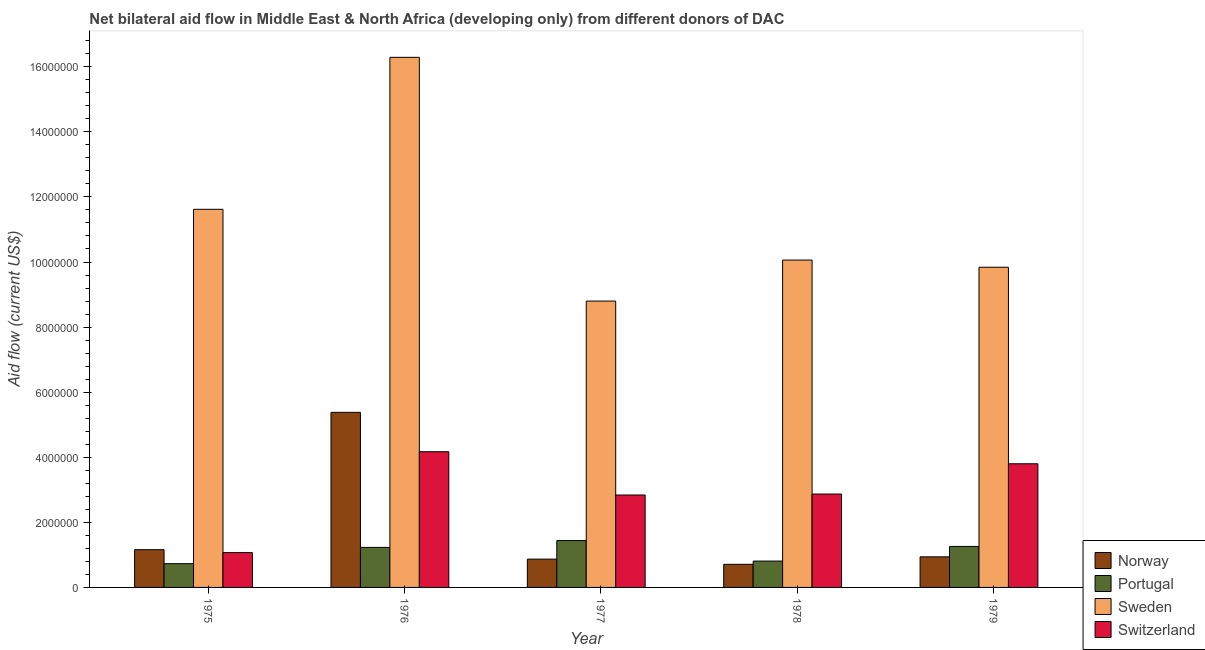How many different coloured bars are there?
Ensure brevity in your answer.  4. Are the number of bars per tick equal to the number of legend labels?
Your answer should be very brief. Yes. Are the number of bars on each tick of the X-axis equal?
Offer a very short reply. Yes. How many bars are there on the 5th tick from the left?
Provide a succinct answer. 4. What is the label of the 1st group of bars from the left?
Provide a succinct answer. 1975. In how many cases, is the number of bars for a given year not equal to the number of legend labels?
Offer a terse response. 0. What is the amount of aid given by norway in 1975?
Offer a very short reply. 1.16e+06. Across all years, what is the maximum amount of aid given by sweden?
Your answer should be very brief. 1.63e+07. Across all years, what is the minimum amount of aid given by norway?
Your response must be concise. 7.10e+05. In which year was the amount of aid given by portugal maximum?
Provide a succinct answer. 1977. In which year was the amount of aid given by portugal minimum?
Keep it short and to the point. 1975. What is the total amount of aid given by portugal in the graph?
Give a very brief answer. 5.47e+06. What is the difference between the amount of aid given by sweden in 1976 and that in 1979?
Keep it short and to the point. 6.45e+06. What is the difference between the amount of aid given by sweden in 1979 and the amount of aid given by portugal in 1975?
Give a very brief answer. -1.78e+06. What is the average amount of aid given by sweden per year?
Keep it short and to the point. 1.13e+07. What is the ratio of the amount of aid given by norway in 1975 to that in 1977?
Your answer should be compact. 1.33. What is the difference between the highest and the second highest amount of aid given by norway?
Ensure brevity in your answer.  4.22e+06. What is the difference between the highest and the lowest amount of aid given by sweden?
Offer a very short reply. 7.49e+06. In how many years, is the amount of aid given by sweden greater than the average amount of aid given by sweden taken over all years?
Your answer should be compact. 2. Is the sum of the amount of aid given by switzerland in 1975 and 1979 greater than the maximum amount of aid given by norway across all years?
Ensure brevity in your answer.  Yes. What does the 2nd bar from the right in 1976 represents?
Provide a succinct answer. Sweden. Are all the bars in the graph horizontal?
Make the answer very short. No. What is the difference between two consecutive major ticks on the Y-axis?
Your answer should be compact. 2.00e+06. Are the values on the major ticks of Y-axis written in scientific E-notation?
Offer a terse response. No. Where does the legend appear in the graph?
Your answer should be compact. Bottom right. What is the title of the graph?
Your answer should be compact. Net bilateral aid flow in Middle East & North Africa (developing only) from different donors of DAC. What is the Aid flow (current US$) of Norway in 1975?
Offer a terse response. 1.16e+06. What is the Aid flow (current US$) in Portugal in 1975?
Ensure brevity in your answer.  7.30e+05. What is the Aid flow (current US$) in Sweden in 1975?
Your answer should be compact. 1.16e+07. What is the Aid flow (current US$) in Switzerland in 1975?
Keep it short and to the point. 1.07e+06. What is the Aid flow (current US$) of Norway in 1976?
Ensure brevity in your answer.  5.38e+06. What is the Aid flow (current US$) in Portugal in 1976?
Your response must be concise. 1.23e+06. What is the Aid flow (current US$) in Sweden in 1976?
Keep it short and to the point. 1.63e+07. What is the Aid flow (current US$) in Switzerland in 1976?
Make the answer very short. 4.17e+06. What is the Aid flow (current US$) in Norway in 1977?
Give a very brief answer. 8.70e+05. What is the Aid flow (current US$) of Portugal in 1977?
Make the answer very short. 1.44e+06. What is the Aid flow (current US$) in Sweden in 1977?
Your response must be concise. 8.80e+06. What is the Aid flow (current US$) in Switzerland in 1977?
Give a very brief answer. 2.84e+06. What is the Aid flow (current US$) in Norway in 1978?
Keep it short and to the point. 7.10e+05. What is the Aid flow (current US$) of Portugal in 1978?
Give a very brief answer. 8.10e+05. What is the Aid flow (current US$) of Sweden in 1978?
Your answer should be very brief. 1.01e+07. What is the Aid flow (current US$) of Switzerland in 1978?
Ensure brevity in your answer.  2.87e+06. What is the Aid flow (current US$) of Norway in 1979?
Offer a very short reply. 9.40e+05. What is the Aid flow (current US$) of Portugal in 1979?
Ensure brevity in your answer.  1.26e+06. What is the Aid flow (current US$) in Sweden in 1979?
Your answer should be compact. 9.84e+06. What is the Aid flow (current US$) of Switzerland in 1979?
Make the answer very short. 3.80e+06. Across all years, what is the maximum Aid flow (current US$) in Norway?
Make the answer very short. 5.38e+06. Across all years, what is the maximum Aid flow (current US$) of Portugal?
Your answer should be compact. 1.44e+06. Across all years, what is the maximum Aid flow (current US$) of Sweden?
Make the answer very short. 1.63e+07. Across all years, what is the maximum Aid flow (current US$) in Switzerland?
Your response must be concise. 4.17e+06. Across all years, what is the minimum Aid flow (current US$) of Norway?
Your response must be concise. 7.10e+05. Across all years, what is the minimum Aid flow (current US$) of Portugal?
Keep it short and to the point. 7.30e+05. Across all years, what is the minimum Aid flow (current US$) of Sweden?
Your response must be concise. 8.80e+06. Across all years, what is the minimum Aid flow (current US$) in Switzerland?
Keep it short and to the point. 1.07e+06. What is the total Aid flow (current US$) in Norway in the graph?
Provide a succinct answer. 9.06e+06. What is the total Aid flow (current US$) in Portugal in the graph?
Provide a succinct answer. 5.47e+06. What is the total Aid flow (current US$) in Sweden in the graph?
Make the answer very short. 5.66e+07. What is the total Aid flow (current US$) of Switzerland in the graph?
Offer a terse response. 1.48e+07. What is the difference between the Aid flow (current US$) of Norway in 1975 and that in 1976?
Your answer should be very brief. -4.22e+06. What is the difference between the Aid flow (current US$) of Portugal in 1975 and that in 1976?
Offer a terse response. -5.00e+05. What is the difference between the Aid flow (current US$) of Sweden in 1975 and that in 1976?
Ensure brevity in your answer.  -4.67e+06. What is the difference between the Aid flow (current US$) in Switzerland in 1975 and that in 1976?
Keep it short and to the point. -3.10e+06. What is the difference between the Aid flow (current US$) in Portugal in 1975 and that in 1977?
Your answer should be very brief. -7.10e+05. What is the difference between the Aid flow (current US$) in Sweden in 1975 and that in 1977?
Make the answer very short. 2.82e+06. What is the difference between the Aid flow (current US$) of Switzerland in 1975 and that in 1977?
Provide a short and direct response. -1.77e+06. What is the difference between the Aid flow (current US$) in Norway in 1975 and that in 1978?
Your answer should be very brief. 4.50e+05. What is the difference between the Aid flow (current US$) of Sweden in 1975 and that in 1978?
Keep it short and to the point. 1.56e+06. What is the difference between the Aid flow (current US$) in Switzerland in 1975 and that in 1978?
Your response must be concise. -1.80e+06. What is the difference between the Aid flow (current US$) of Portugal in 1975 and that in 1979?
Provide a succinct answer. -5.30e+05. What is the difference between the Aid flow (current US$) of Sweden in 1975 and that in 1979?
Offer a very short reply. 1.78e+06. What is the difference between the Aid flow (current US$) in Switzerland in 1975 and that in 1979?
Offer a very short reply. -2.73e+06. What is the difference between the Aid flow (current US$) of Norway in 1976 and that in 1977?
Your answer should be very brief. 4.51e+06. What is the difference between the Aid flow (current US$) in Portugal in 1976 and that in 1977?
Make the answer very short. -2.10e+05. What is the difference between the Aid flow (current US$) of Sweden in 1976 and that in 1977?
Your answer should be compact. 7.49e+06. What is the difference between the Aid flow (current US$) in Switzerland in 1976 and that in 1977?
Ensure brevity in your answer.  1.33e+06. What is the difference between the Aid flow (current US$) of Norway in 1976 and that in 1978?
Keep it short and to the point. 4.67e+06. What is the difference between the Aid flow (current US$) in Sweden in 1976 and that in 1978?
Keep it short and to the point. 6.23e+06. What is the difference between the Aid flow (current US$) in Switzerland in 1976 and that in 1978?
Provide a short and direct response. 1.30e+06. What is the difference between the Aid flow (current US$) of Norway in 1976 and that in 1979?
Offer a very short reply. 4.44e+06. What is the difference between the Aid flow (current US$) in Sweden in 1976 and that in 1979?
Make the answer very short. 6.45e+06. What is the difference between the Aid flow (current US$) of Switzerland in 1976 and that in 1979?
Your answer should be compact. 3.70e+05. What is the difference between the Aid flow (current US$) of Portugal in 1977 and that in 1978?
Make the answer very short. 6.30e+05. What is the difference between the Aid flow (current US$) of Sweden in 1977 and that in 1978?
Give a very brief answer. -1.26e+06. What is the difference between the Aid flow (current US$) in Portugal in 1977 and that in 1979?
Ensure brevity in your answer.  1.80e+05. What is the difference between the Aid flow (current US$) in Sweden in 1977 and that in 1979?
Provide a succinct answer. -1.04e+06. What is the difference between the Aid flow (current US$) of Switzerland in 1977 and that in 1979?
Keep it short and to the point. -9.60e+05. What is the difference between the Aid flow (current US$) of Norway in 1978 and that in 1979?
Keep it short and to the point. -2.30e+05. What is the difference between the Aid flow (current US$) in Portugal in 1978 and that in 1979?
Keep it short and to the point. -4.50e+05. What is the difference between the Aid flow (current US$) in Sweden in 1978 and that in 1979?
Provide a succinct answer. 2.20e+05. What is the difference between the Aid flow (current US$) of Switzerland in 1978 and that in 1979?
Make the answer very short. -9.30e+05. What is the difference between the Aid flow (current US$) in Norway in 1975 and the Aid flow (current US$) in Sweden in 1976?
Ensure brevity in your answer.  -1.51e+07. What is the difference between the Aid flow (current US$) in Norway in 1975 and the Aid flow (current US$) in Switzerland in 1976?
Offer a very short reply. -3.01e+06. What is the difference between the Aid flow (current US$) of Portugal in 1975 and the Aid flow (current US$) of Sweden in 1976?
Provide a succinct answer. -1.56e+07. What is the difference between the Aid flow (current US$) of Portugal in 1975 and the Aid flow (current US$) of Switzerland in 1976?
Your answer should be compact. -3.44e+06. What is the difference between the Aid flow (current US$) in Sweden in 1975 and the Aid flow (current US$) in Switzerland in 1976?
Provide a short and direct response. 7.45e+06. What is the difference between the Aid flow (current US$) of Norway in 1975 and the Aid flow (current US$) of Portugal in 1977?
Keep it short and to the point. -2.80e+05. What is the difference between the Aid flow (current US$) in Norway in 1975 and the Aid flow (current US$) in Sweden in 1977?
Keep it short and to the point. -7.64e+06. What is the difference between the Aid flow (current US$) of Norway in 1975 and the Aid flow (current US$) of Switzerland in 1977?
Provide a short and direct response. -1.68e+06. What is the difference between the Aid flow (current US$) in Portugal in 1975 and the Aid flow (current US$) in Sweden in 1977?
Offer a terse response. -8.07e+06. What is the difference between the Aid flow (current US$) in Portugal in 1975 and the Aid flow (current US$) in Switzerland in 1977?
Make the answer very short. -2.11e+06. What is the difference between the Aid flow (current US$) in Sweden in 1975 and the Aid flow (current US$) in Switzerland in 1977?
Offer a very short reply. 8.78e+06. What is the difference between the Aid flow (current US$) in Norway in 1975 and the Aid flow (current US$) in Sweden in 1978?
Ensure brevity in your answer.  -8.90e+06. What is the difference between the Aid flow (current US$) of Norway in 1975 and the Aid flow (current US$) of Switzerland in 1978?
Make the answer very short. -1.71e+06. What is the difference between the Aid flow (current US$) of Portugal in 1975 and the Aid flow (current US$) of Sweden in 1978?
Offer a very short reply. -9.33e+06. What is the difference between the Aid flow (current US$) of Portugal in 1975 and the Aid flow (current US$) of Switzerland in 1978?
Your answer should be compact. -2.14e+06. What is the difference between the Aid flow (current US$) of Sweden in 1975 and the Aid flow (current US$) of Switzerland in 1978?
Provide a succinct answer. 8.75e+06. What is the difference between the Aid flow (current US$) of Norway in 1975 and the Aid flow (current US$) of Sweden in 1979?
Make the answer very short. -8.68e+06. What is the difference between the Aid flow (current US$) of Norway in 1975 and the Aid flow (current US$) of Switzerland in 1979?
Provide a succinct answer. -2.64e+06. What is the difference between the Aid flow (current US$) of Portugal in 1975 and the Aid flow (current US$) of Sweden in 1979?
Offer a very short reply. -9.11e+06. What is the difference between the Aid flow (current US$) in Portugal in 1975 and the Aid flow (current US$) in Switzerland in 1979?
Offer a terse response. -3.07e+06. What is the difference between the Aid flow (current US$) in Sweden in 1975 and the Aid flow (current US$) in Switzerland in 1979?
Ensure brevity in your answer.  7.82e+06. What is the difference between the Aid flow (current US$) of Norway in 1976 and the Aid flow (current US$) of Portugal in 1977?
Make the answer very short. 3.94e+06. What is the difference between the Aid flow (current US$) of Norway in 1976 and the Aid flow (current US$) of Sweden in 1977?
Provide a short and direct response. -3.42e+06. What is the difference between the Aid flow (current US$) of Norway in 1976 and the Aid flow (current US$) of Switzerland in 1977?
Your answer should be compact. 2.54e+06. What is the difference between the Aid flow (current US$) of Portugal in 1976 and the Aid flow (current US$) of Sweden in 1977?
Provide a short and direct response. -7.57e+06. What is the difference between the Aid flow (current US$) of Portugal in 1976 and the Aid flow (current US$) of Switzerland in 1977?
Keep it short and to the point. -1.61e+06. What is the difference between the Aid flow (current US$) in Sweden in 1976 and the Aid flow (current US$) in Switzerland in 1977?
Your answer should be very brief. 1.34e+07. What is the difference between the Aid flow (current US$) in Norway in 1976 and the Aid flow (current US$) in Portugal in 1978?
Provide a succinct answer. 4.57e+06. What is the difference between the Aid flow (current US$) in Norway in 1976 and the Aid flow (current US$) in Sweden in 1978?
Your answer should be very brief. -4.68e+06. What is the difference between the Aid flow (current US$) of Norway in 1976 and the Aid flow (current US$) of Switzerland in 1978?
Provide a succinct answer. 2.51e+06. What is the difference between the Aid flow (current US$) in Portugal in 1976 and the Aid flow (current US$) in Sweden in 1978?
Make the answer very short. -8.83e+06. What is the difference between the Aid flow (current US$) of Portugal in 1976 and the Aid flow (current US$) of Switzerland in 1978?
Make the answer very short. -1.64e+06. What is the difference between the Aid flow (current US$) in Sweden in 1976 and the Aid flow (current US$) in Switzerland in 1978?
Offer a terse response. 1.34e+07. What is the difference between the Aid flow (current US$) of Norway in 1976 and the Aid flow (current US$) of Portugal in 1979?
Provide a succinct answer. 4.12e+06. What is the difference between the Aid flow (current US$) in Norway in 1976 and the Aid flow (current US$) in Sweden in 1979?
Ensure brevity in your answer.  -4.46e+06. What is the difference between the Aid flow (current US$) of Norway in 1976 and the Aid flow (current US$) of Switzerland in 1979?
Provide a short and direct response. 1.58e+06. What is the difference between the Aid flow (current US$) in Portugal in 1976 and the Aid flow (current US$) in Sweden in 1979?
Offer a very short reply. -8.61e+06. What is the difference between the Aid flow (current US$) of Portugal in 1976 and the Aid flow (current US$) of Switzerland in 1979?
Provide a short and direct response. -2.57e+06. What is the difference between the Aid flow (current US$) in Sweden in 1976 and the Aid flow (current US$) in Switzerland in 1979?
Give a very brief answer. 1.25e+07. What is the difference between the Aid flow (current US$) in Norway in 1977 and the Aid flow (current US$) in Portugal in 1978?
Your answer should be very brief. 6.00e+04. What is the difference between the Aid flow (current US$) of Norway in 1977 and the Aid flow (current US$) of Sweden in 1978?
Your answer should be compact. -9.19e+06. What is the difference between the Aid flow (current US$) of Norway in 1977 and the Aid flow (current US$) of Switzerland in 1978?
Your answer should be compact. -2.00e+06. What is the difference between the Aid flow (current US$) in Portugal in 1977 and the Aid flow (current US$) in Sweden in 1978?
Give a very brief answer. -8.62e+06. What is the difference between the Aid flow (current US$) in Portugal in 1977 and the Aid flow (current US$) in Switzerland in 1978?
Keep it short and to the point. -1.43e+06. What is the difference between the Aid flow (current US$) of Sweden in 1977 and the Aid flow (current US$) of Switzerland in 1978?
Make the answer very short. 5.93e+06. What is the difference between the Aid flow (current US$) in Norway in 1977 and the Aid flow (current US$) in Portugal in 1979?
Offer a very short reply. -3.90e+05. What is the difference between the Aid flow (current US$) in Norway in 1977 and the Aid flow (current US$) in Sweden in 1979?
Your answer should be compact. -8.97e+06. What is the difference between the Aid flow (current US$) of Norway in 1977 and the Aid flow (current US$) of Switzerland in 1979?
Your answer should be very brief. -2.93e+06. What is the difference between the Aid flow (current US$) of Portugal in 1977 and the Aid flow (current US$) of Sweden in 1979?
Give a very brief answer. -8.40e+06. What is the difference between the Aid flow (current US$) in Portugal in 1977 and the Aid flow (current US$) in Switzerland in 1979?
Your answer should be very brief. -2.36e+06. What is the difference between the Aid flow (current US$) of Norway in 1978 and the Aid flow (current US$) of Portugal in 1979?
Provide a succinct answer. -5.50e+05. What is the difference between the Aid flow (current US$) in Norway in 1978 and the Aid flow (current US$) in Sweden in 1979?
Make the answer very short. -9.13e+06. What is the difference between the Aid flow (current US$) of Norway in 1978 and the Aid flow (current US$) of Switzerland in 1979?
Give a very brief answer. -3.09e+06. What is the difference between the Aid flow (current US$) in Portugal in 1978 and the Aid flow (current US$) in Sweden in 1979?
Make the answer very short. -9.03e+06. What is the difference between the Aid flow (current US$) of Portugal in 1978 and the Aid flow (current US$) of Switzerland in 1979?
Offer a very short reply. -2.99e+06. What is the difference between the Aid flow (current US$) of Sweden in 1978 and the Aid flow (current US$) of Switzerland in 1979?
Keep it short and to the point. 6.26e+06. What is the average Aid flow (current US$) of Norway per year?
Offer a very short reply. 1.81e+06. What is the average Aid flow (current US$) of Portugal per year?
Keep it short and to the point. 1.09e+06. What is the average Aid flow (current US$) of Sweden per year?
Provide a short and direct response. 1.13e+07. What is the average Aid flow (current US$) in Switzerland per year?
Your answer should be very brief. 2.95e+06. In the year 1975, what is the difference between the Aid flow (current US$) in Norway and Aid flow (current US$) in Sweden?
Ensure brevity in your answer.  -1.05e+07. In the year 1975, what is the difference between the Aid flow (current US$) of Norway and Aid flow (current US$) of Switzerland?
Your answer should be very brief. 9.00e+04. In the year 1975, what is the difference between the Aid flow (current US$) of Portugal and Aid flow (current US$) of Sweden?
Your answer should be compact. -1.09e+07. In the year 1975, what is the difference between the Aid flow (current US$) of Sweden and Aid flow (current US$) of Switzerland?
Keep it short and to the point. 1.06e+07. In the year 1976, what is the difference between the Aid flow (current US$) in Norway and Aid flow (current US$) in Portugal?
Your answer should be very brief. 4.15e+06. In the year 1976, what is the difference between the Aid flow (current US$) in Norway and Aid flow (current US$) in Sweden?
Ensure brevity in your answer.  -1.09e+07. In the year 1976, what is the difference between the Aid flow (current US$) of Norway and Aid flow (current US$) of Switzerland?
Offer a terse response. 1.21e+06. In the year 1976, what is the difference between the Aid flow (current US$) in Portugal and Aid flow (current US$) in Sweden?
Keep it short and to the point. -1.51e+07. In the year 1976, what is the difference between the Aid flow (current US$) in Portugal and Aid flow (current US$) in Switzerland?
Offer a very short reply. -2.94e+06. In the year 1976, what is the difference between the Aid flow (current US$) of Sweden and Aid flow (current US$) of Switzerland?
Your answer should be very brief. 1.21e+07. In the year 1977, what is the difference between the Aid flow (current US$) of Norway and Aid flow (current US$) of Portugal?
Make the answer very short. -5.70e+05. In the year 1977, what is the difference between the Aid flow (current US$) of Norway and Aid flow (current US$) of Sweden?
Your answer should be compact. -7.93e+06. In the year 1977, what is the difference between the Aid flow (current US$) in Norway and Aid flow (current US$) in Switzerland?
Offer a terse response. -1.97e+06. In the year 1977, what is the difference between the Aid flow (current US$) in Portugal and Aid flow (current US$) in Sweden?
Offer a very short reply. -7.36e+06. In the year 1977, what is the difference between the Aid flow (current US$) in Portugal and Aid flow (current US$) in Switzerland?
Your response must be concise. -1.40e+06. In the year 1977, what is the difference between the Aid flow (current US$) of Sweden and Aid flow (current US$) of Switzerland?
Give a very brief answer. 5.96e+06. In the year 1978, what is the difference between the Aid flow (current US$) in Norway and Aid flow (current US$) in Sweden?
Offer a very short reply. -9.35e+06. In the year 1978, what is the difference between the Aid flow (current US$) in Norway and Aid flow (current US$) in Switzerland?
Make the answer very short. -2.16e+06. In the year 1978, what is the difference between the Aid flow (current US$) in Portugal and Aid flow (current US$) in Sweden?
Keep it short and to the point. -9.25e+06. In the year 1978, what is the difference between the Aid flow (current US$) in Portugal and Aid flow (current US$) in Switzerland?
Offer a terse response. -2.06e+06. In the year 1978, what is the difference between the Aid flow (current US$) of Sweden and Aid flow (current US$) of Switzerland?
Provide a short and direct response. 7.19e+06. In the year 1979, what is the difference between the Aid flow (current US$) in Norway and Aid flow (current US$) in Portugal?
Your answer should be compact. -3.20e+05. In the year 1979, what is the difference between the Aid flow (current US$) in Norway and Aid flow (current US$) in Sweden?
Ensure brevity in your answer.  -8.90e+06. In the year 1979, what is the difference between the Aid flow (current US$) of Norway and Aid flow (current US$) of Switzerland?
Your answer should be compact. -2.86e+06. In the year 1979, what is the difference between the Aid flow (current US$) in Portugal and Aid flow (current US$) in Sweden?
Ensure brevity in your answer.  -8.58e+06. In the year 1979, what is the difference between the Aid flow (current US$) in Portugal and Aid flow (current US$) in Switzerland?
Your answer should be very brief. -2.54e+06. In the year 1979, what is the difference between the Aid flow (current US$) in Sweden and Aid flow (current US$) in Switzerland?
Your answer should be very brief. 6.04e+06. What is the ratio of the Aid flow (current US$) of Norway in 1975 to that in 1976?
Offer a very short reply. 0.22. What is the ratio of the Aid flow (current US$) of Portugal in 1975 to that in 1976?
Provide a short and direct response. 0.59. What is the ratio of the Aid flow (current US$) of Sweden in 1975 to that in 1976?
Keep it short and to the point. 0.71. What is the ratio of the Aid flow (current US$) in Switzerland in 1975 to that in 1976?
Make the answer very short. 0.26. What is the ratio of the Aid flow (current US$) in Portugal in 1975 to that in 1977?
Offer a very short reply. 0.51. What is the ratio of the Aid flow (current US$) of Sweden in 1975 to that in 1977?
Your response must be concise. 1.32. What is the ratio of the Aid flow (current US$) in Switzerland in 1975 to that in 1977?
Your answer should be compact. 0.38. What is the ratio of the Aid flow (current US$) in Norway in 1975 to that in 1978?
Provide a short and direct response. 1.63. What is the ratio of the Aid flow (current US$) in Portugal in 1975 to that in 1978?
Keep it short and to the point. 0.9. What is the ratio of the Aid flow (current US$) in Sweden in 1975 to that in 1978?
Provide a succinct answer. 1.16. What is the ratio of the Aid flow (current US$) of Switzerland in 1975 to that in 1978?
Provide a short and direct response. 0.37. What is the ratio of the Aid flow (current US$) of Norway in 1975 to that in 1979?
Keep it short and to the point. 1.23. What is the ratio of the Aid flow (current US$) in Portugal in 1975 to that in 1979?
Your response must be concise. 0.58. What is the ratio of the Aid flow (current US$) in Sweden in 1975 to that in 1979?
Your answer should be very brief. 1.18. What is the ratio of the Aid flow (current US$) of Switzerland in 1975 to that in 1979?
Provide a short and direct response. 0.28. What is the ratio of the Aid flow (current US$) in Norway in 1976 to that in 1977?
Your answer should be compact. 6.18. What is the ratio of the Aid flow (current US$) of Portugal in 1976 to that in 1977?
Keep it short and to the point. 0.85. What is the ratio of the Aid flow (current US$) of Sweden in 1976 to that in 1977?
Provide a succinct answer. 1.85. What is the ratio of the Aid flow (current US$) of Switzerland in 1976 to that in 1977?
Your answer should be compact. 1.47. What is the ratio of the Aid flow (current US$) in Norway in 1976 to that in 1978?
Make the answer very short. 7.58. What is the ratio of the Aid flow (current US$) of Portugal in 1976 to that in 1978?
Offer a very short reply. 1.52. What is the ratio of the Aid flow (current US$) in Sweden in 1976 to that in 1978?
Offer a terse response. 1.62. What is the ratio of the Aid flow (current US$) of Switzerland in 1976 to that in 1978?
Offer a terse response. 1.45. What is the ratio of the Aid flow (current US$) in Norway in 1976 to that in 1979?
Keep it short and to the point. 5.72. What is the ratio of the Aid flow (current US$) of Portugal in 1976 to that in 1979?
Provide a succinct answer. 0.98. What is the ratio of the Aid flow (current US$) of Sweden in 1976 to that in 1979?
Keep it short and to the point. 1.66. What is the ratio of the Aid flow (current US$) in Switzerland in 1976 to that in 1979?
Your response must be concise. 1.1. What is the ratio of the Aid flow (current US$) of Norway in 1977 to that in 1978?
Provide a short and direct response. 1.23. What is the ratio of the Aid flow (current US$) of Portugal in 1977 to that in 1978?
Give a very brief answer. 1.78. What is the ratio of the Aid flow (current US$) in Sweden in 1977 to that in 1978?
Offer a very short reply. 0.87. What is the ratio of the Aid flow (current US$) of Norway in 1977 to that in 1979?
Your answer should be compact. 0.93. What is the ratio of the Aid flow (current US$) in Portugal in 1977 to that in 1979?
Your answer should be very brief. 1.14. What is the ratio of the Aid flow (current US$) in Sweden in 1977 to that in 1979?
Provide a succinct answer. 0.89. What is the ratio of the Aid flow (current US$) in Switzerland in 1977 to that in 1979?
Offer a very short reply. 0.75. What is the ratio of the Aid flow (current US$) of Norway in 1978 to that in 1979?
Offer a terse response. 0.76. What is the ratio of the Aid flow (current US$) of Portugal in 1978 to that in 1979?
Your answer should be compact. 0.64. What is the ratio of the Aid flow (current US$) of Sweden in 1978 to that in 1979?
Make the answer very short. 1.02. What is the ratio of the Aid flow (current US$) of Switzerland in 1978 to that in 1979?
Provide a succinct answer. 0.76. What is the difference between the highest and the second highest Aid flow (current US$) of Norway?
Give a very brief answer. 4.22e+06. What is the difference between the highest and the second highest Aid flow (current US$) in Portugal?
Give a very brief answer. 1.80e+05. What is the difference between the highest and the second highest Aid flow (current US$) of Sweden?
Provide a succinct answer. 4.67e+06. What is the difference between the highest and the second highest Aid flow (current US$) in Switzerland?
Make the answer very short. 3.70e+05. What is the difference between the highest and the lowest Aid flow (current US$) in Norway?
Provide a succinct answer. 4.67e+06. What is the difference between the highest and the lowest Aid flow (current US$) of Portugal?
Offer a very short reply. 7.10e+05. What is the difference between the highest and the lowest Aid flow (current US$) in Sweden?
Keep it short and to the point. 7.49e+06. What is the difference between the highest and the lowest Aid flow (current US$) in Switzerland?
Give a very brief answer. 3.10e+06. 